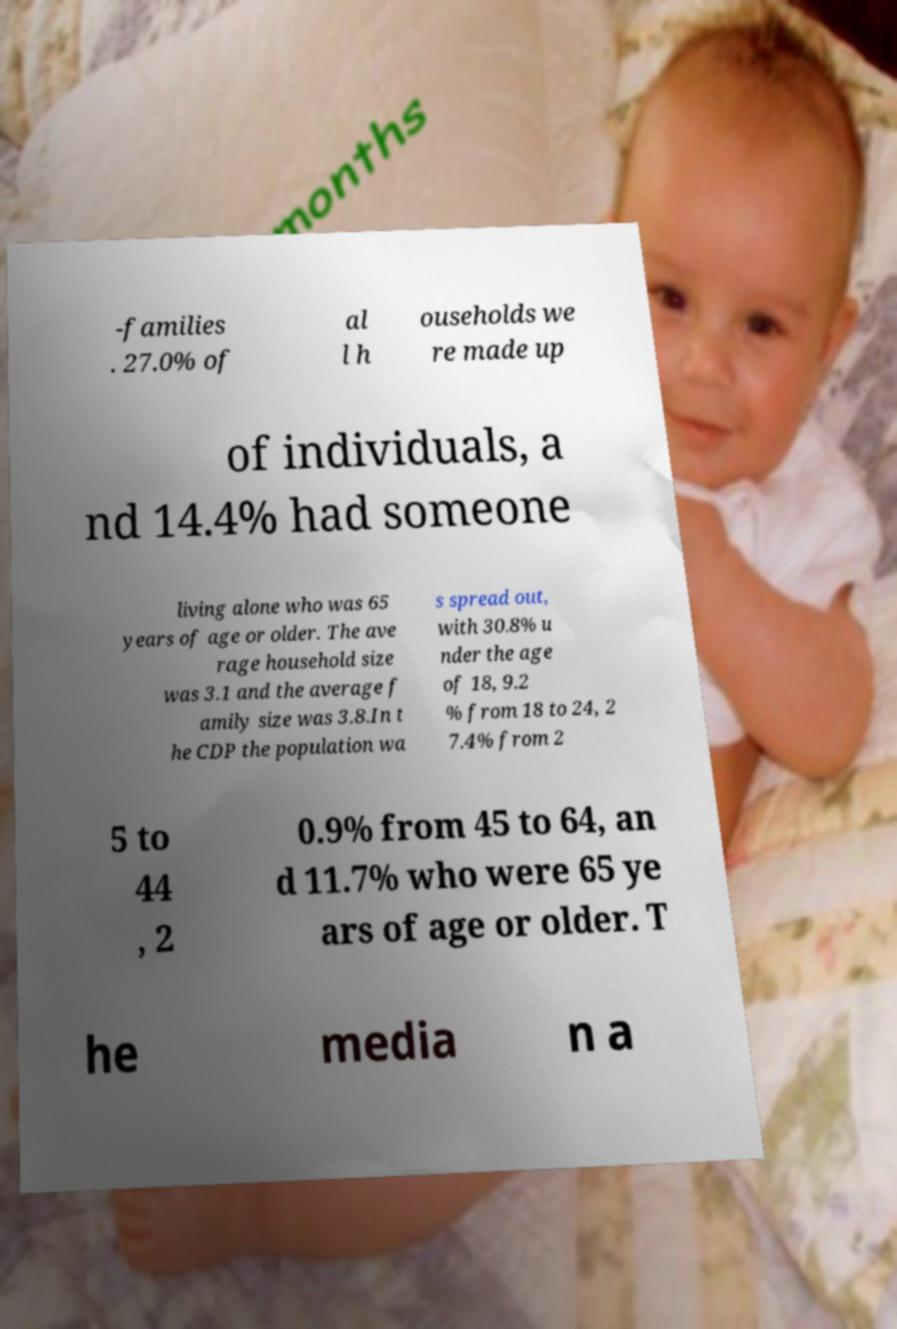What messages or text are displayed in this image? I need them in a readable, typed format. -families . 27.0% of al l h ouseholds we re made up of individuals, a nd 14.4% had someone living alone who was 65 years of age or older. The ave rage household size was 3.1 and the average f amily size was 3.8.In t he CDP the population wa s spread out, with 30.8% u nder the age of 18, 9.2 % from 18 to 24, 2 7.4% from 2 5 to 44 , 2 0.9% from 45 to 64, an d 11.7% who were 65 ye ars of age or older. T he media n a 